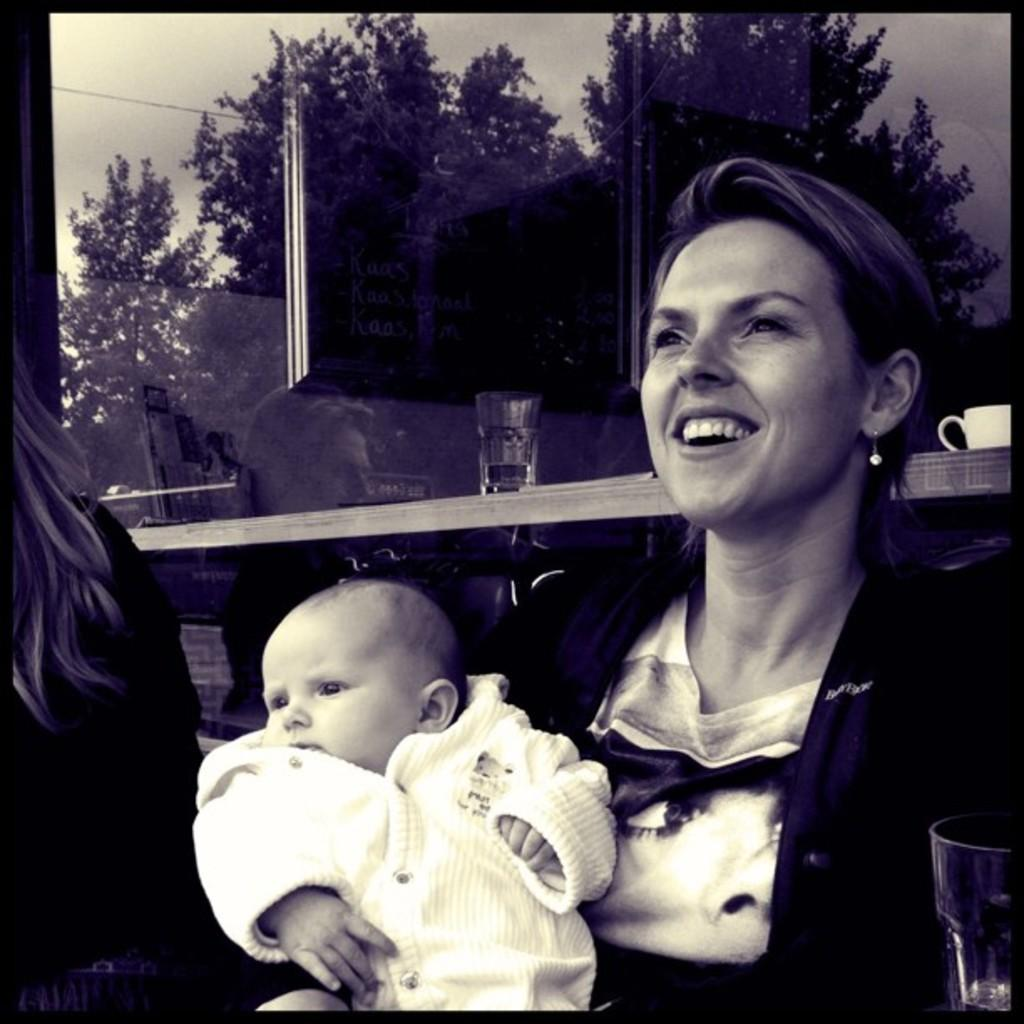Who is the main subject in the image? There is a woman in the image. What is the woman doing in the image? The woman is holding a baby in her hands. What can be seen in the background reflection? There is a reflection of trees, the sky, a glass tumbler, advertisements, a coffee mug, and a reflection of a woman in the background. Can you see a deer, a tiger, or the earth in the image? No, there are no deer, tigers, or the earth visible in the image. 